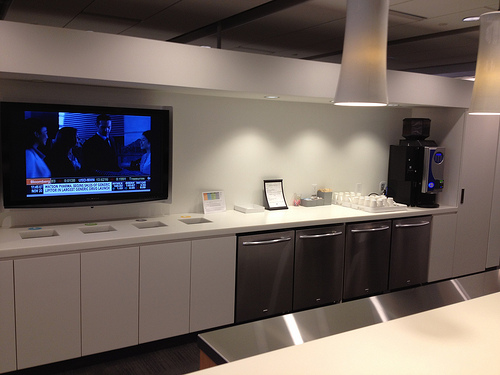Please provide a short description for this region: [0.0, 0.33, 0.34, 0.53]. This area shows a television that is currently on. 